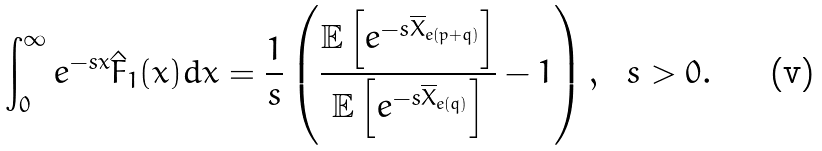<formula> <loc_0><loc_0><loc_500><loc_500>& \int _ { 0 } ^ { \infty } e ^ { - s x } \hat { F } _ { 1 } ( x ) d x = \frac { 1 } { s } \left ( \frac { \mathbb { E } \left [ e ^ { - s \overline { X } _ { e ( p + q ) } } \right ] } { \mathbb { E } \left [ e ^ { - s \overline { X } _ { e ( q ) } } \right ] } - 1 \right ) , \ \ s > 0 .</formula> 